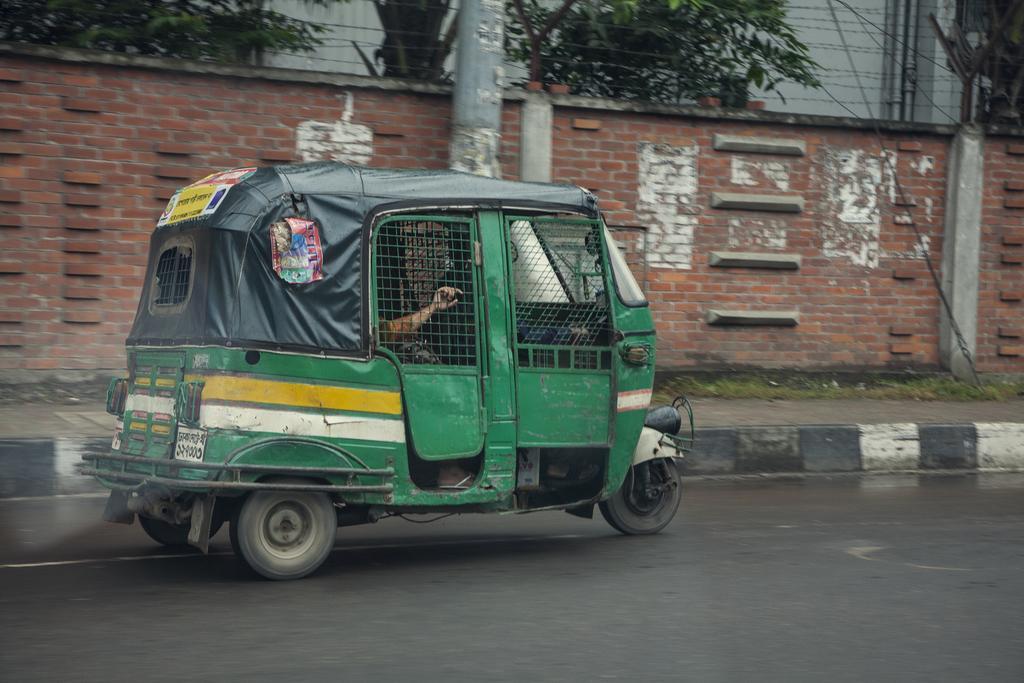Can you describe this image briefly? In this image there is an auto rickshaw is moving on the road, inside it there are two persons. In the background there is boundary, pole, trees. This is a sidewalk. These are grass. 